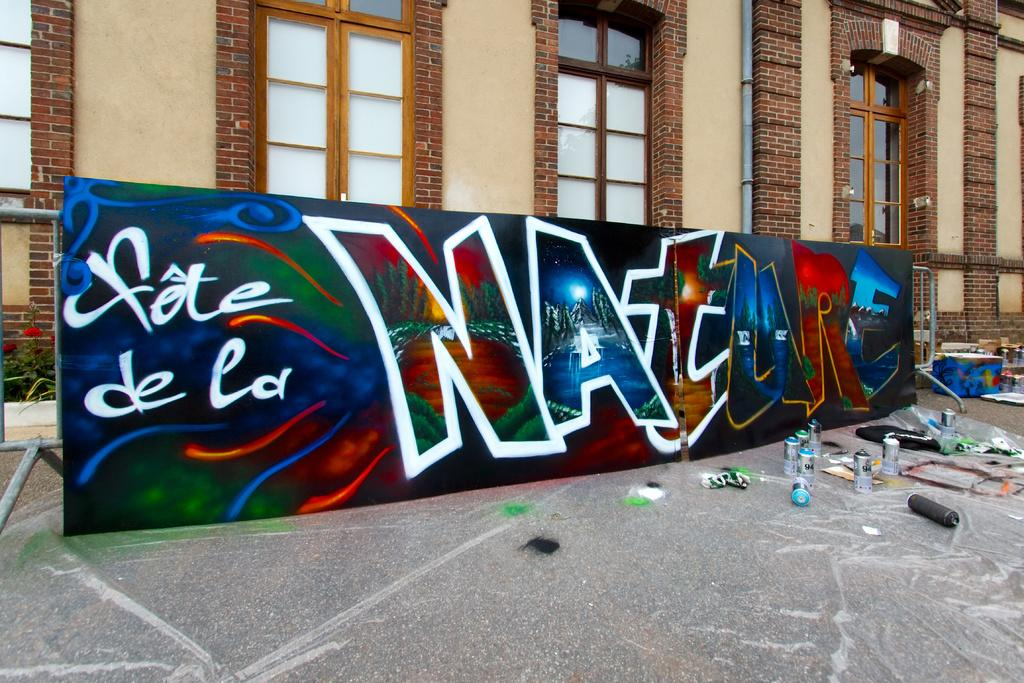What is the main object in the center of the image? There is a board in the center of the image. What can be seen on the floor near the board? There are graffiti bottles on the floor. What is visible in the background of the image? There are windows, a pipe, and a building in the background of the image. How many kittens are sitting on the sofa in the image? There is no sofa or kittens present in the image. 